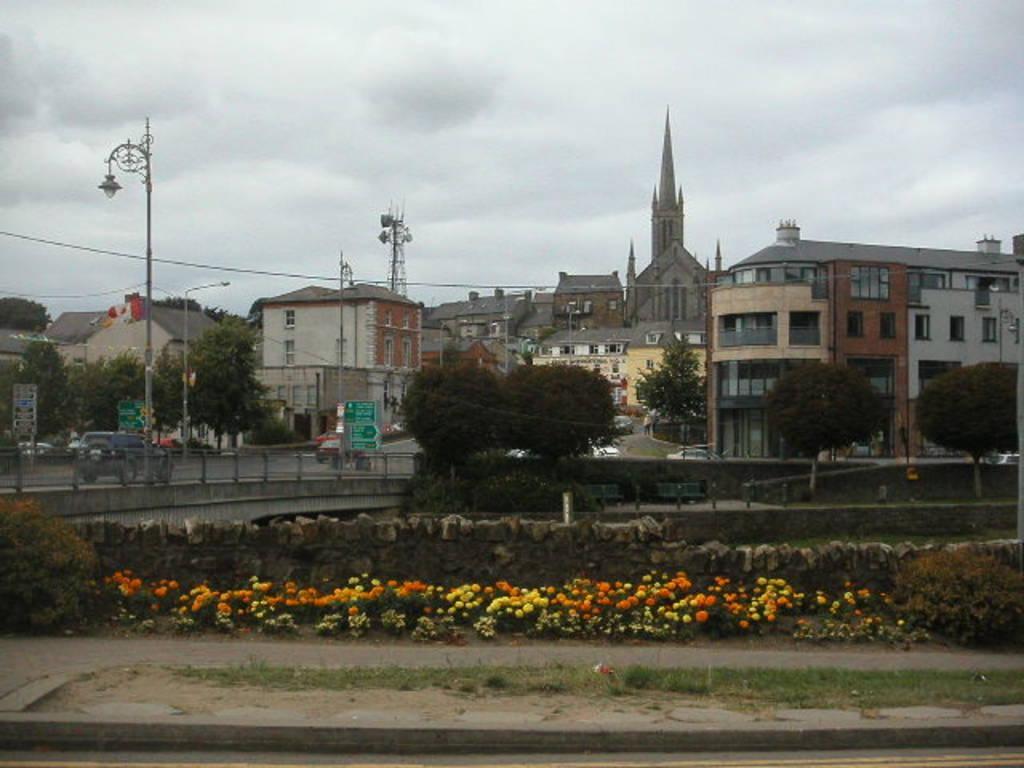How would you summarize this image in a sentence or two? In this image there are buildings and trees. We can see poles. At the bottom there are shrubs and we can see flowers. On the left there is a bridge and we can see vehicles on the bridge. There are boards. At the top there is sky. 